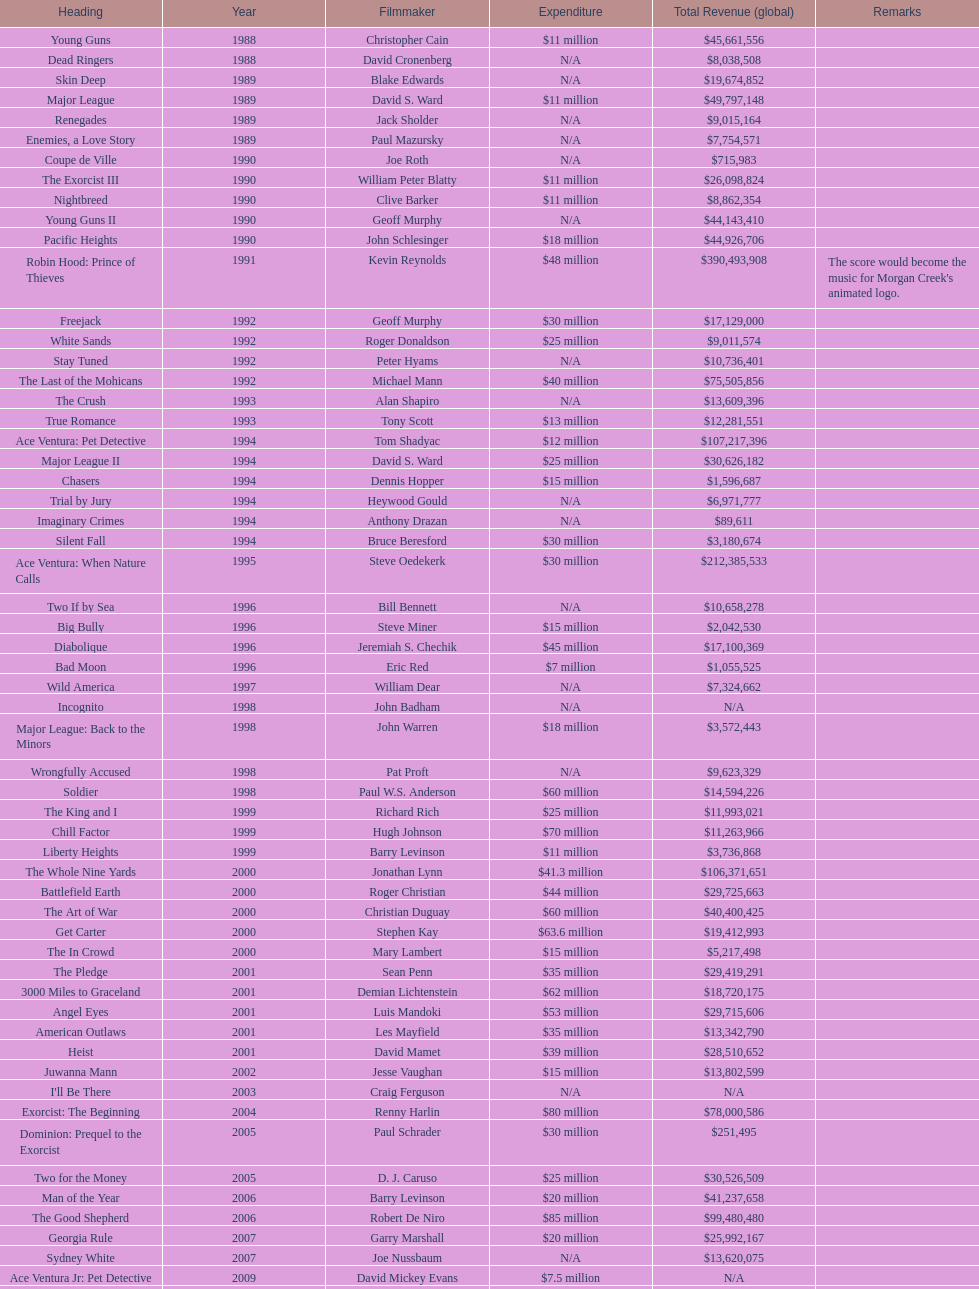Which morgan creek film grossed the most worldwide? Robin Hood: Prince of Thieves. 